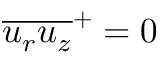<formula> <loc_0><loc_0><loc_500><loc_500>\overline { { u _ { r } u _ { z } } } ^ { + } = 0</formula> 